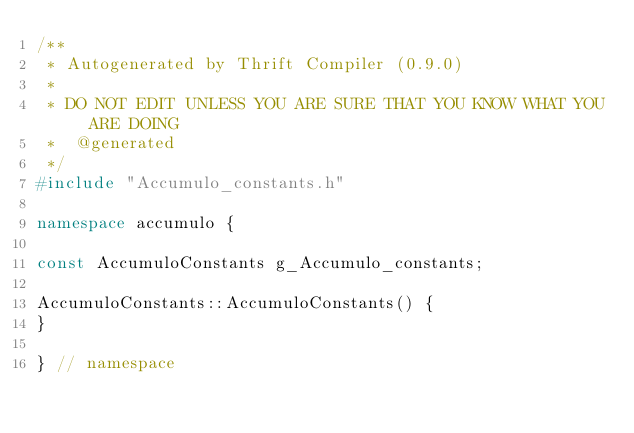Convert code to text. <code><loc_0><loc_0><loc_500><loc_500><_C++_>/**
 * Autogenerated by Thrift Compiler (0.9.0)
 *
 * DO NOT EDIT UNLESS YOU ARE SURE THAT YOU KNOW WHAT YOU ARE DOING
 *  @generated
 */
#include "Accumulo_constants.h"

namespace accumulo {

const AccumuloConstants g_Accumulo_constants;

AccumuloConstants::AccumuloConstants() {
}

} // namespace

</code> 